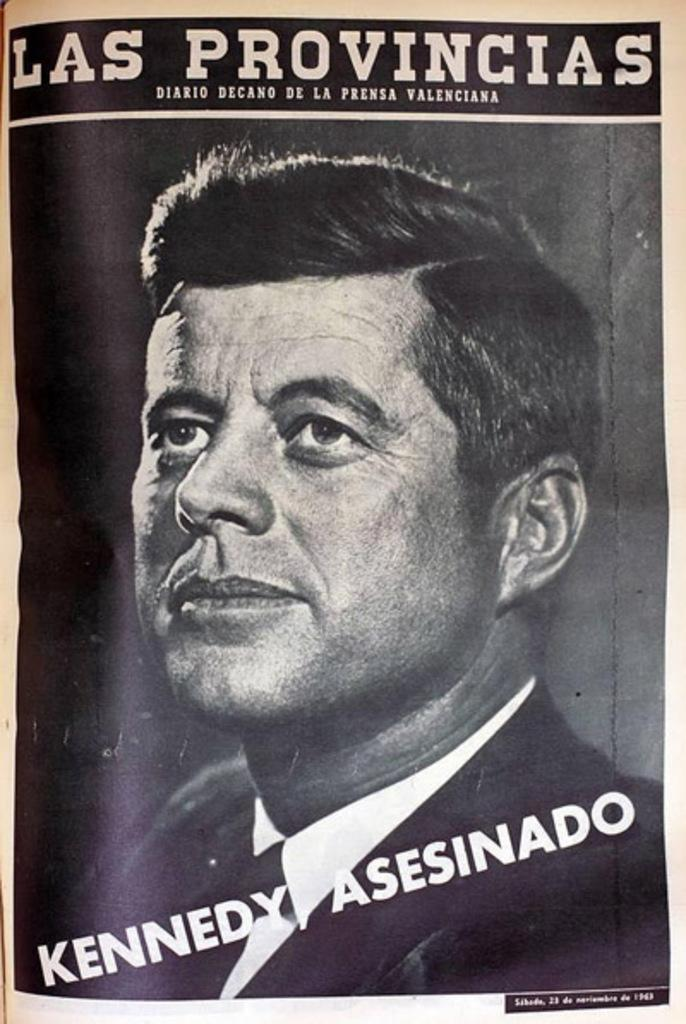<image>
Create a compact narrative representing the image presented. A picture of President Kennedy has the title Las Provincias. 